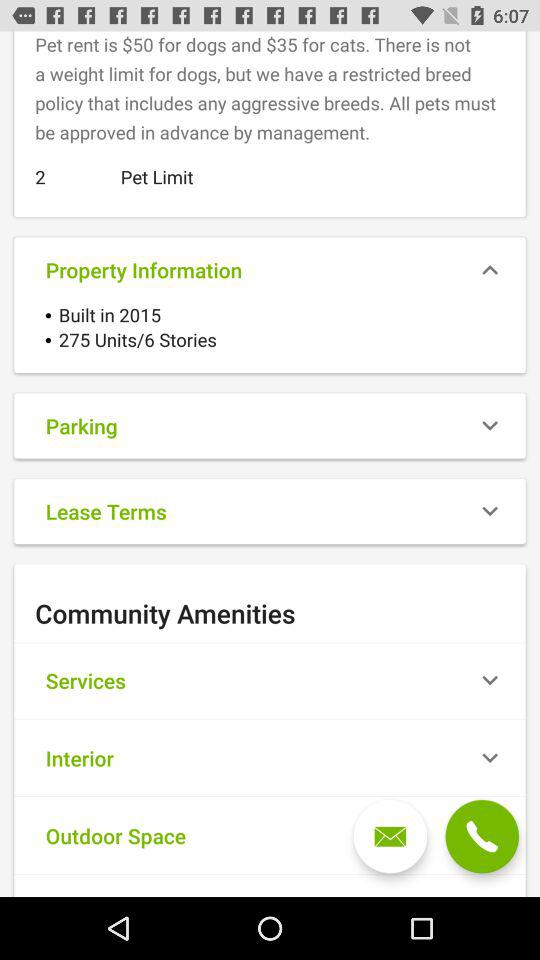What is the unit count? The unit count is 275. 